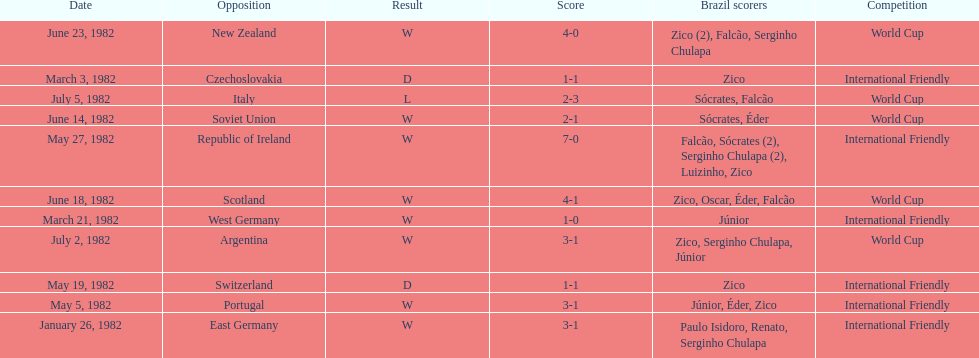How many games did zico end up scoring in during this season? 7. 